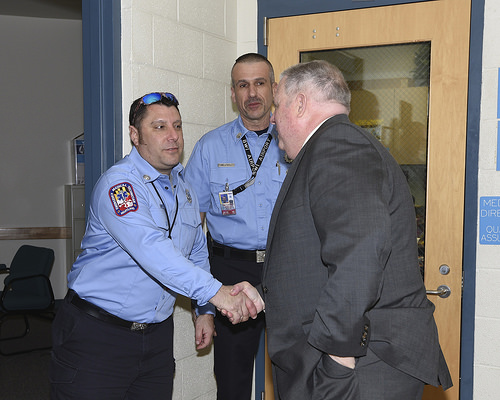<image>
Is there a man in front of the door? Yes. The man is positioned in front of the door, appearing closer to the camera viewpoint. 